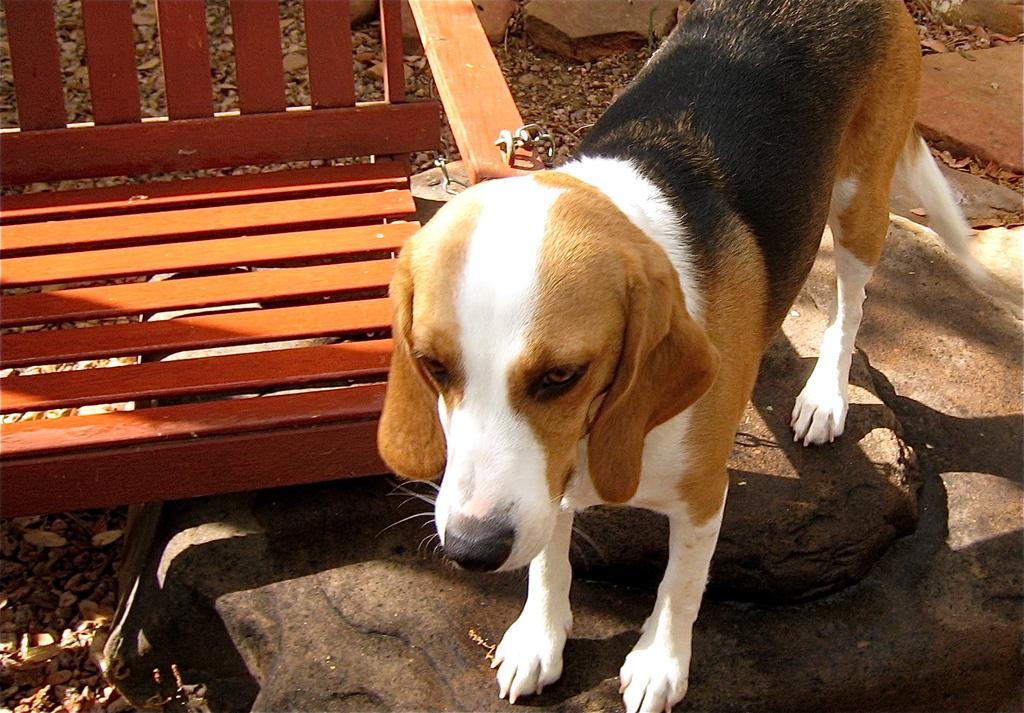In one or two sentences, can you explain what this image depicts? In this picture there is a dog who is standing near to the wooden table. On the right we can see stones. On the bottom left corner we can see the leaves. 